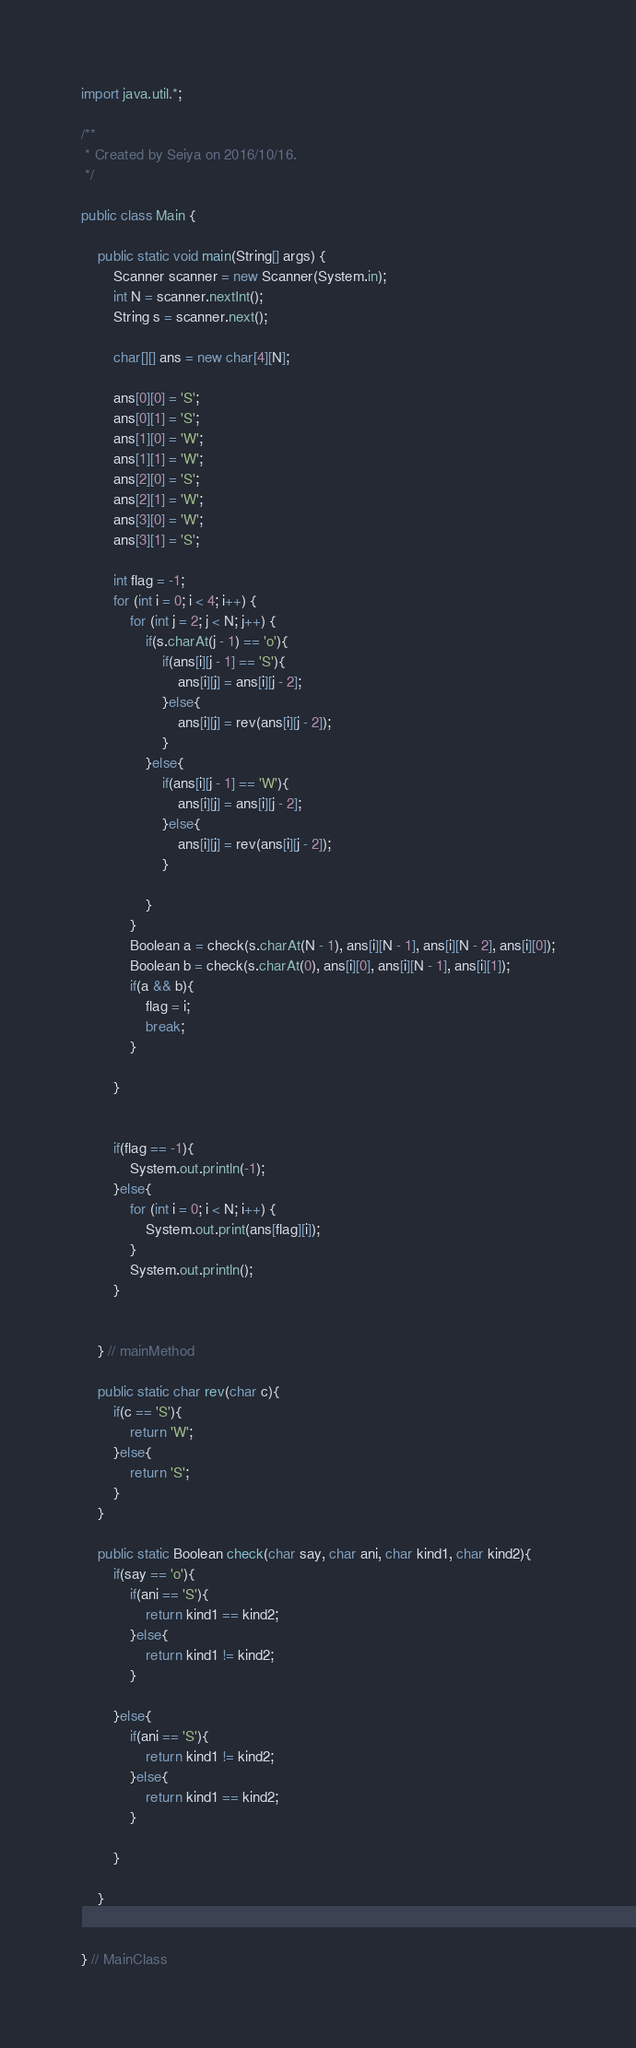<code> <loc_0><loc_0><loc_500><loc_500><_Java_>import java.util.*;

/**
 * Created by Seiya on 2016/10/16.
 */

public class Main {

    public static void main(String[] args) {
        Scanner scanner = new Scanner(System.in);
        int N = scanner.nextInt();
        String s = scanner.next();

        char[][] ans = new char[4][N];

        ans[0][0] = 'S';
        ans[0][1] = 'S';
        ans[1][0] = 'W';
        ans[1][1] = 'W';
        ans[2][0] = 'S';
        ans[2][1] = 'W';
        ans[3][0] = 'W';
        ans[3][1] = 'S';

        int flag = -1;
        for (int i = 0; i < 4; i++) {
            for (int j = 2; j < N; j++) {
                if(s.charAt(j - 1) == 'o'){
                    if(ans[i][j - 1] == 'S'){
                        ans[i][j] = ans[i][j - 2];
                    }else{
                        ans[i][j] = rev(ans[i][j - 2]);
                    }
                }else{
                    if(ans[i][j - 1] == 'W'){
                        ans[i][j] = ans[i][j - 2];
                    }else{
                        ans[i][j] = rev(ans[i][j - 2]);
                    }

                }
            }
            Boolean a = check(s.charAt(N - 1), ans[i][N - 1], ans[i][N - 2], ans[i][0]);
            Boolean b = check(s.charAt(0), ans[i][0], ans[i][N - 1], ans[i][1]);
            if(a && b){
                flag = i;
                break;
            }

        }


        if(flag == -1){
            System.out.println(-1);
        }else{
            for (int i = 0; i < N; i++) {
                System.out.print(ans[flag][i]);
            }
            System.out.println();
        }


    } // mainMethod

    public static char rev(char c){
        if(c == 'S'){
            return 'W';
        }else{
            return 'S';
        }
    }

    public static Boolean check(char say, char ani, char kind1, char kind2){
        if(say == 'o'){
            if(ani == 'S'){
                return kind1 == kind2;
            }else{
                return kind1 != kind2;
            }

        }else{
            if(ani == 'S'){
                return kind1 != kind2;
            }else{
                return kind1 == kind2;
            }

        }

    }


} // MainClass
</code> 